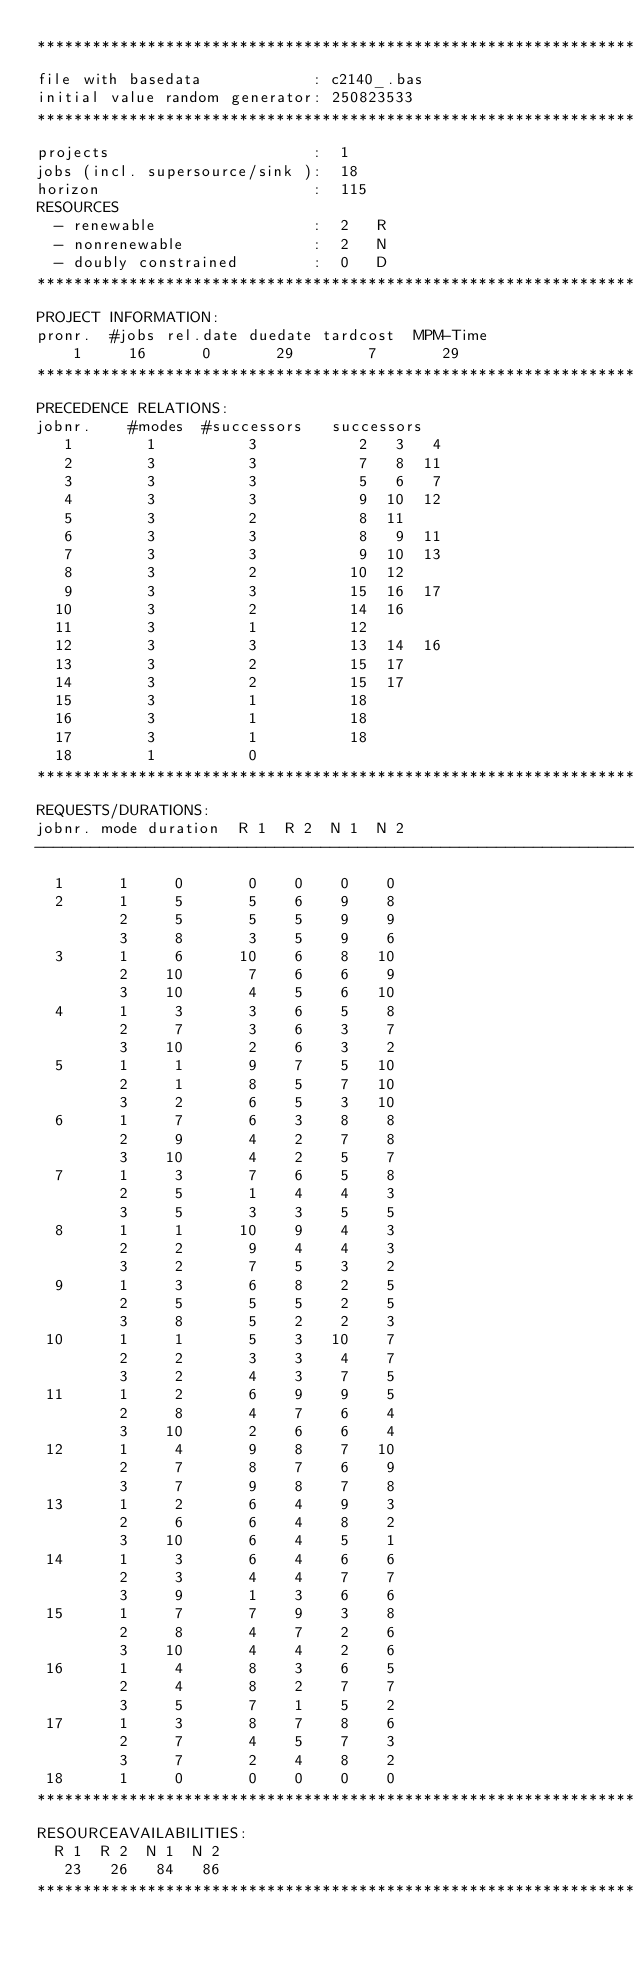Convert code to text. <code><loc_0><loc_0><loc_500><loc_500><_ObjectiveC_>************************************************************************
file with basedata            : c2140_.bas
initial value random generator: 250823533
************************************************************************
projects                      :  1
jobs (incl. supersource/sink ):  18
horizon                       :  115
RESOURCES
  - renewable                 :  2   R
  - nonrenewable              :  2   N
  - doubly constrained        :  0   D
************************************************************************
PROJECT INFORMATION:
pronr.  #jobs rel.date duedate tardcost  MPM-Time
    1     16      0       29        7       29
************************************************************************
PRECEDENCE RELATIONS:
jobnr.    #modes  #successors   successors
   1        1          3           2   3   4
   2        3          3           7   8  11
   3        3          3           5   6   7
   4        3          3           9  10  12
   5        3          2           8  11
   6        3          3           8   9  11
   7        3          3           9  10  13
   8        3          2          10  12
   9        3          3          15  16  17
  10        3          2          14  16
  11        3          1          12
  12        3          3          13  14  16
  13        3          2          15  17
  14        3          2          15  17
  15        3          1          18
  16        3          1          18
  17        3          1          18
  18        1          0        
************************************************************************
REQUESTS/DURATIONS:
jobnr. mode duration  R 1  R 2  N 1  N 2
------------------------------------------------------------------------
  1      1     0       0    0    0    0
  2      1     5       5    6    9    8
         2     5       5    5    9    9
         3     8       3    5    9    6
  3      1     6      10    6    8   10
         2    10       7    6    6    9
         3    10       4    5    6   10
  4      1     3       3    6    5    8
         2     7       3    6    3    7
         3    10       2    6    3    2
  5      1     1       9    7    5   10
         2     1       8    5    7   10
         3     2       6    5    3   10
  6      1     7       6    3    8    8
         2     9       4    2    7    8
         3    10       4    2    5    7
  7      1     3       7    6    5    8
         2     5       1    4    4    3
         3     5       3    3    5    5
  8      1     1      10    9    4    3
         2     2       9    4    4    3
         3     2       7    5    3    2
  9      1     3       6    8    2    5
         2     5       5    5    2    5
         3     8       5    2    2    3
 10      1     1       5    3   10    7
         2     2       3    3    4    7
         3     2       4    3    7    5
 11      1     2       6    9    9    5
         2     8       4    7    6    4
         3    10       2    6    6    4
 12      1     4       9    8    7   10
         2     7       8    7    6    9
         3     7       9    8    7    8
 13      1     2       6    4    9    3
         2     6       6    4    8    2
         3    10       6    4    5    1
 14      1     3       6    4    6    6
         2     3       4    4    7    7
         3     9       1    3    6    6
 15      1     7       7    9    3    8
         2     8       4    7    2    6
         3    10       4    4    2    6
 16      1     4       8    3    6    5
         2     4       8    2    7    7
         3     5       7    1    5    2
 17      1     3       8    7    8    6
         2     7       4    5    7    3
         3     7       2    4    8    2
 18      1     0       0    0    0    0
************************************************************************
RESOURCEAVAILABILITIES:
  R 1  R 2  N 1  N 2
   23   26   84   86
************************************************************************
</code> 